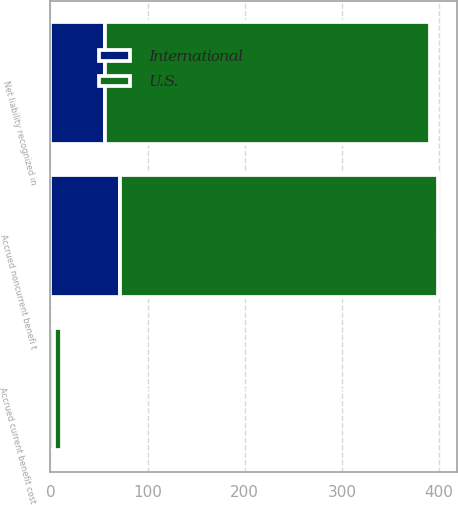<chart> <loc_0><loc_0><loc_500><loc_500><stacked_bar_chart><ecel><fcel>Accrued current benefit cost<fcel>Accrued noncurrent benefi t<fcel>Net liability recognized in<nl><fcel>U.S.<fcel>7.7<fcel>326.9<fcel>334.6<nl><fcel>International<fcel>4<fcel>71.6<fcel>56.2<nl></chart> 